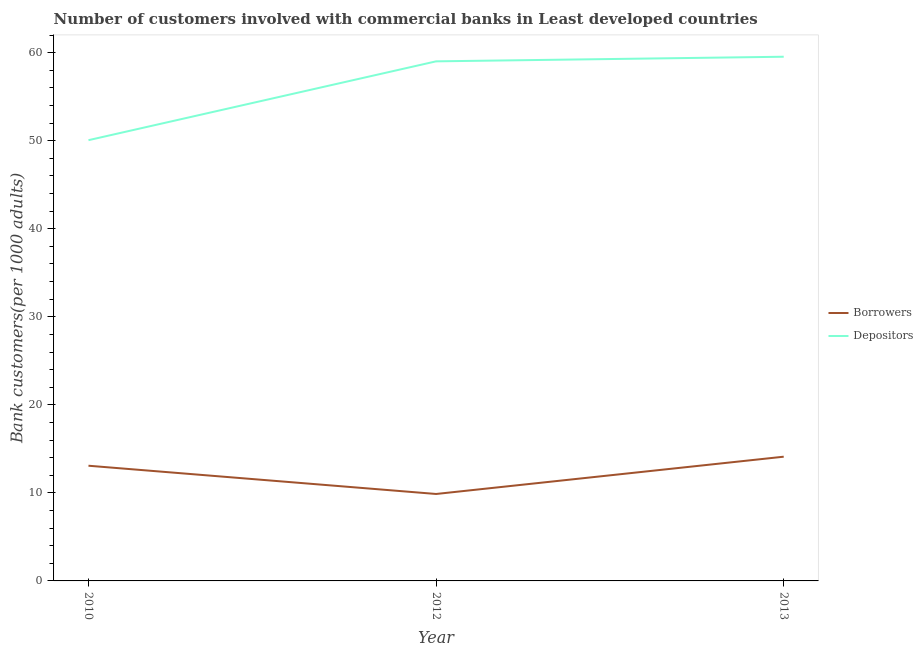Does the line corresponding to number of borrowers intersect with the line corresponding to number of depositors?
Your answer should be compact. No. Is the number of lines equal to the number of legend labels?
Offer a terse response. Yes. What is the number of depositors in 2010?
Your response must be concise. 50.06. Across all years, what is the maximum number of borrowers?
Ensure brevity in your answer.  14.11. Across all years, what is the minimum number of depositors?
Make the answer very short. 50.06. In which year was the number of depositors minimum?
Keep it short and to the point. 2010. What is the total number of borrowers in the graph?
Provide a short and direct response. 37.07. What is the difference between the number of depositors in 2010 and that in 2013?
Make the answer very short. -9.48. What is the difference between the number of borrowers in 2012 and the number of depositors in 2013?
Offer a terse response. -49.66. What is the average number of depositors per year?
Ensure brevity in your answer.  56.21. In the year 2012, what is the difference between the number of borrowers and number of depositors?
Your answer should be very brief. -49.14. What is the ratio of the number of borrowers in 2010 to that in 2012?
Offer a very short reply. 1.32. Is the difference between the number of borrowers in 2010 and 2012 greater than the difference between the number of depositors in 2010 and 2012?
Keep it short and to the point. Yes. What is the difference between the highest and the second highest number of depositors?
Your answer should be compact. 0.52. What is the difference between the highest and the lowest number of depositors?
Offer a very short reply. 9.48. Is the sum of the number of borrowers in 2012 and 2013 greater than the maximum number of depositors across all years?
Provide a succinct answer. No. How many lines are there?
Provide a succinct answer. 2. How many years are there in the graph?
Give a very brief answer. 3. What is the difference between two consecutive major ticks on the Y-axis?
Keep it short and to the point. 10. Are the values on the major ticks of Y-axis written in scientific E-notation?
Ensure brevity in your answer.  No. Does the graph contain any zero values?
Give a very brief answer. No. Where does the legend appear in the graph?
Keep it short and to the point. Center right. How are the legend labels stacked?
Offer a terse response. Vertical. What is the title of the graph?
Give a very brief answer. Number of customers involved with commercial banks in Least developed countries. Does "Crop" appear as one of the legend labels in the graph?
Offer a very short reply. No. What is the label or title of the Y-axis?
Ensure brevity in your answer.  Bank customers(per 1000 adults). What is the Bank customers(per 1000 adults) in Borrowers in 2010?
Offer a very short reply. 13.08. What is the Bank customers(per 1000 adults) in Depositors in 2010?
Ensure brevity in your answer.  50.06. What is the Bank customers(per 1000 adults) in Borrowers in 2012?
Keep it short and to the point. 9.88. What is the Bank customers(per 1000 adults) in Depositors in 2012?
Make the answer very short. 59.02. What is the Bank customers(per 1000 adults) in Borrowers in 2013?
Offer a very short reply. 14.11. What is the Bank customers(per 1000 adults) in Depositors in 2013?
Give a very brief answer. 59.54. Across all years, what is the maximum Bank customers(per 1000 adults) of Borrowers?
Give a very brief answer. 14.11. Across all years, what is the maximum Bank customers(per 1000 adults) of Depositors?
Provide a succinct answer. 59.54. Across all years, what is the minimum Bank customers(per 1000 adults) in Borrowers?
Offer a terse response. 9.88. Across all years, what is the minimum Bank customers(per 1000 adults) of Depositors?
Ensure brevity in your answer.  50.06. What is the total Bank customers(per 1000 adults) of Borrowers in the graph?
Offer a terse response. 37.07. What is the total Bank customers(per 1000 adults) in Depositors in the graph?
Provide a succinct answer. 168.62. What is the difference between the Bank customers(per 1000 adults) in Borrowers in 2010 and that in 2012?
Make the answer very short. 3.21. What is the difference between the Bank customers(per 1000 adults) of Depositors in 2010 and that in 2012?
Your answer should be compact. -8.95. What is the difference between the Bank customers(per 1000 adults) in Borrowers in 2010 and that in 2013?
Your answer should be compact. -1.03. What is the difference between the Bank customers(per 1000 adults) of Depositors in 2010 and that in 2013?
Provide a succinct answer. -9.48. What is the difference between the Bank customers(per 1000 adults) in Borrowers in 2012 and that in 2013?
Make the answer very short. -4.23. What is the difference between the Bank customers(per 1000 adults) in Depositors in 2012 and that in 2013?
Keep it short and to the point. -0.52. What is the difference between the Bank customers(per 1000 adults) of Borrowers in 2010 and the Bank customers(per 1000 adults) of Depositors in 2012?
Make the answer very short. -45.93. What is the difference between the Bank customers(per 1000 adults) in Borrowers in 2010 and the Bank customers(per 1000 adults) in Depositors in 2013?
Give a very brief answer. -46.45. What is the difference between the Bank customers(per 1000 adults) of Borrowers in 2012 and the Bank customers(per 1000 adults) of Depositors in 2013?
Provide a succinct answer. -49.66. What is the average Bank customers(per 1000 adults) in Borrowers per year?
Your answer should be compact. 12.36. What is the average Bank customers(per 1000 adults) of Depositors per year?
Make the answer very short. 56.2. In the year 2010, what is the difference between the Bank customers(per 1000 adults) in Borrowers and Bank customers(per 1000 adults) in Depositors?
Your answer should be very brief. -36.98. In the year 2012, what is the difference between the Bank customers(per 1000 adults) of Borrowers and Bank customers(per 1000 adults) of Depositors?
Keep it short and to the point. -49.14. In the year 2013, what is the difference between the Bank customers(per 1000 adults) in Borrowers and Bank customers(per 1000 adults) in Depositors?
Make the answer very short. -45.43. What is the ratio of the Bank customers(per 1000 adults) of Borrowers in 2010 to that in 2012?
Ensure brevity in your answer.  1.32. What is the ratio of the Bank customers(per 1000 adults) in Depositors in 2010 to that in 2012?
Your response must be concise. 0.85. What is the ratio of the Bank customers(per 1000 adults) in Borrowers in 2010 to that in 2013?
Offer a very short reply. 0.93. What is the ratio of the Bank customers(per 1000 adults) of Depositors in 2010 to that in 2013?
Make the answer very short. 0.84. What is the ratio of the Bank customers(per 1000 adults) in Borrowers in 2012 to that in 2013?
Make the answer very short. 0.7. What is the difference between the highest and the second highest Bank customers(per 1000 adults) in Borrowers?
Provide a short and direct response. 1.03. What is the difference between the highest and the second highest Bank customers(per 1000 adults) in Depositors?
Offer a terse response. 0.52. What is the difference between the highest and the lowest Bank customers(per 1000 adults) of Borrowers?
Provide a succinct answer. 4.23. What is the difference between the highest and the lowest Bank customers(per 1000 adults) in Depositors?
Offer a very short reply. 9.48. 